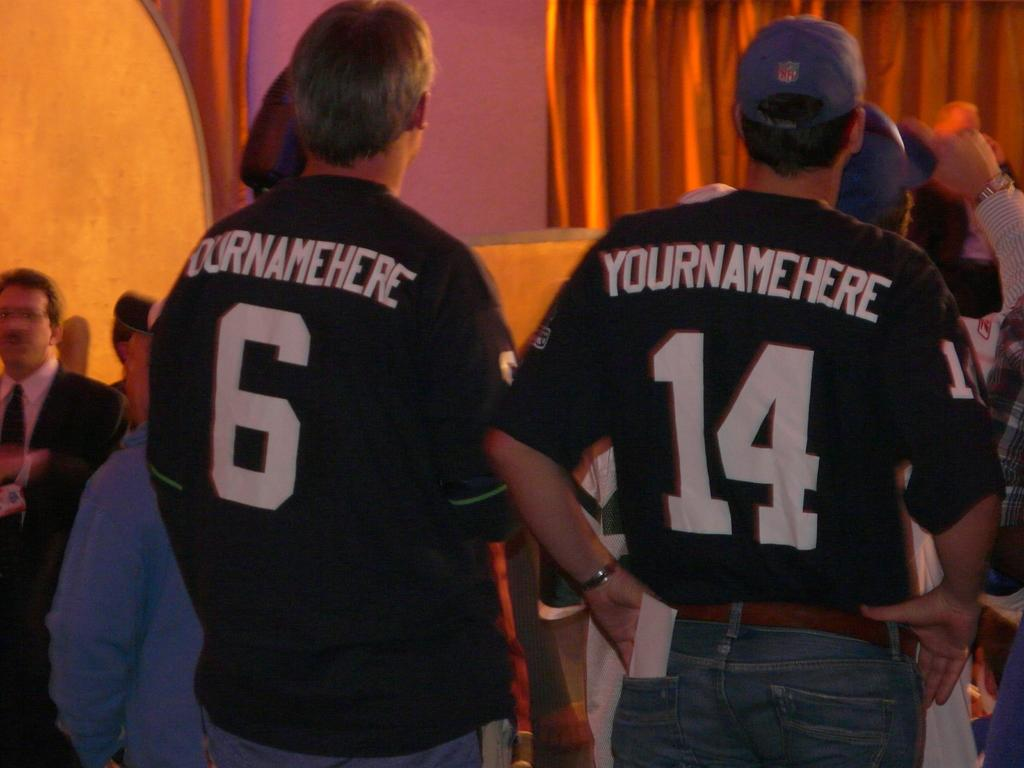<image>
Write a terse but informative summary of the picture. Two men are standing in a crowd and their shirts both say Yournamehere. 